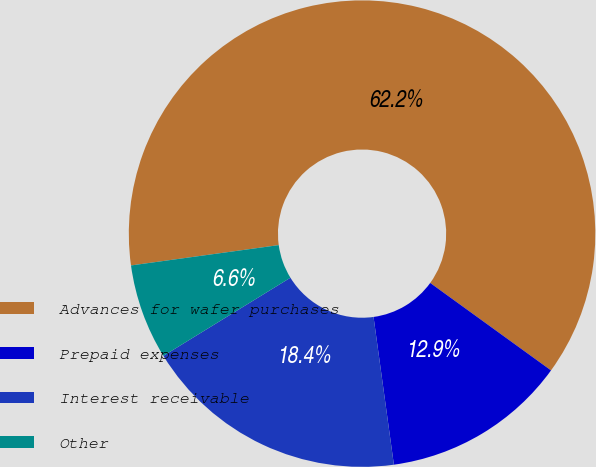<chart> <loc_0><loc_0><loc_500><loc_500><pie_chart><fcel>Advances for wafer purchases<fcel>Prepaid expenses<fcel>Interest receivable<fcel>Other<nl><fcel>62.15%<fcel>12.85%<fcel>18.4%<fcel>6.6%<nl></chart> 